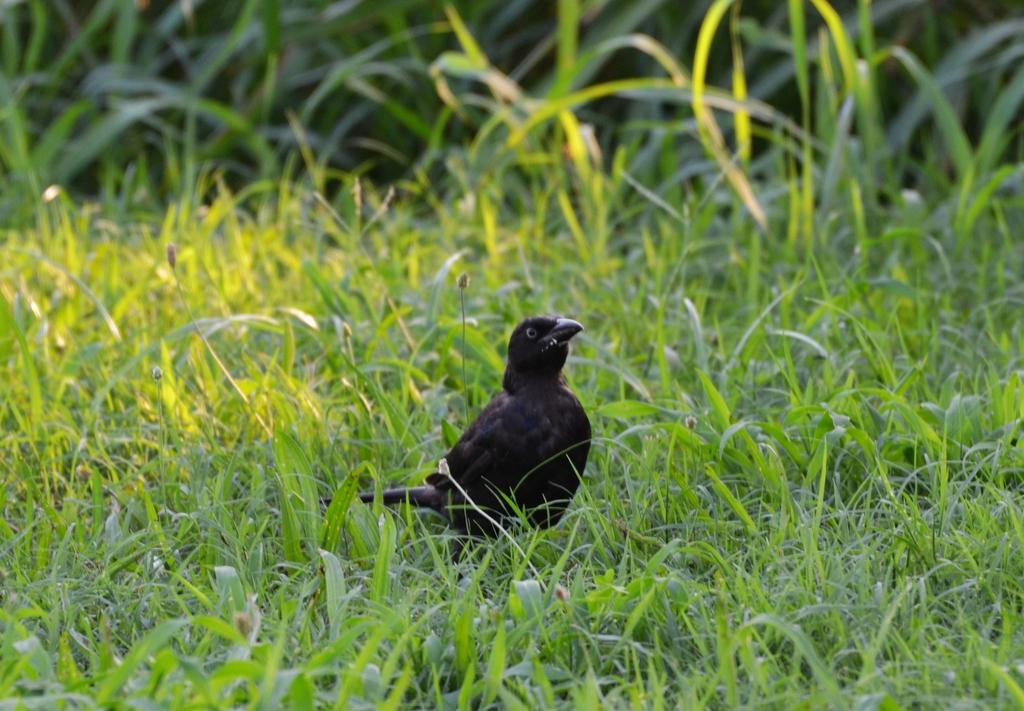What type of animal can be seen in the image? There is a bird in the image. Where is the bird located in the image? The bird is standing on the land. What type of vegetation is present in the image? There is grass in the image. What type of flame can be seen burning in the image? There is no flame present in the image; it features a bird standing on the land. How does the bird show respect to the other animals in the image? The image does not depict any other animals, so it is not possible to determine how the bird might show respect. 